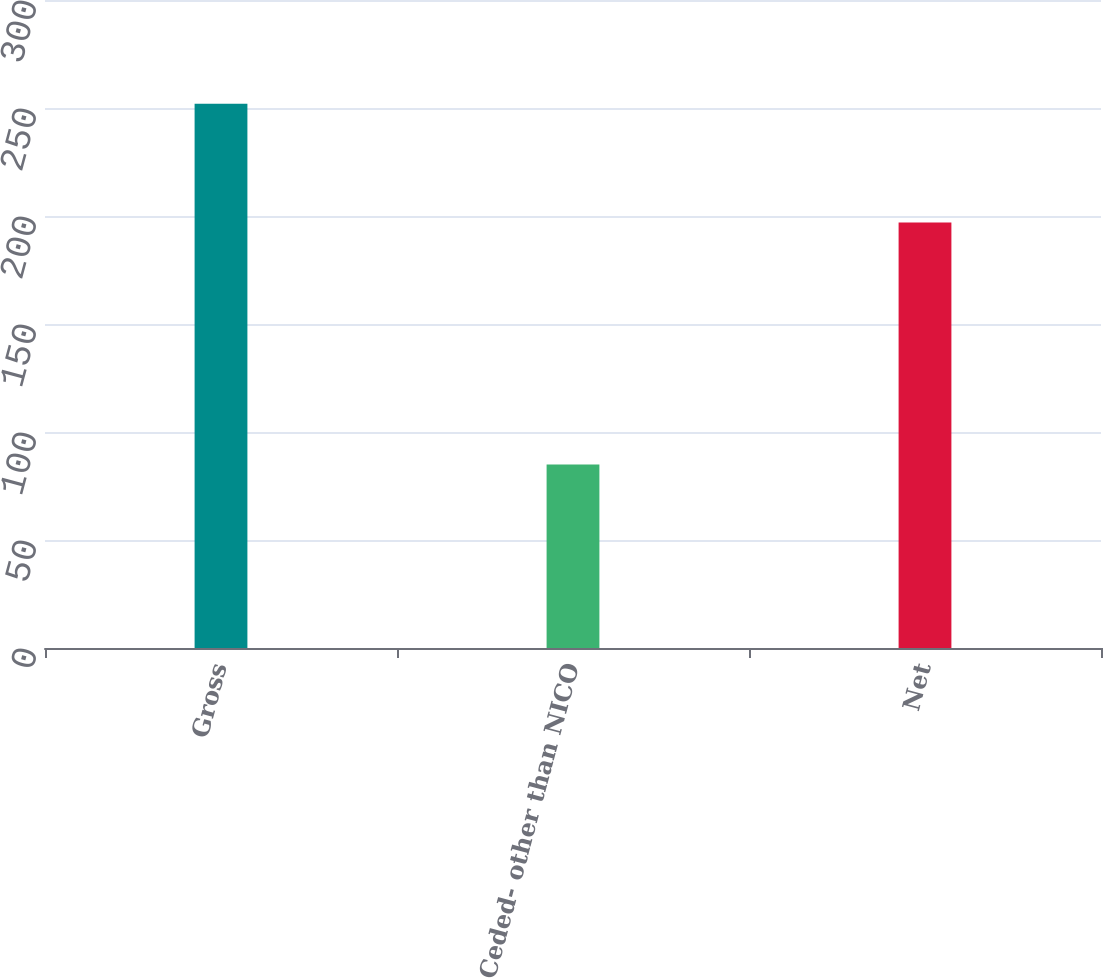Convert chart. <chart><loc_0><loc_0><loc_500><loc_500><bar_chart><fcel>Gross<fcel>Ceded- other than NICO<fcel>Net<nl><fcel>252<fcel>85<fcel>197<nl></chart> 